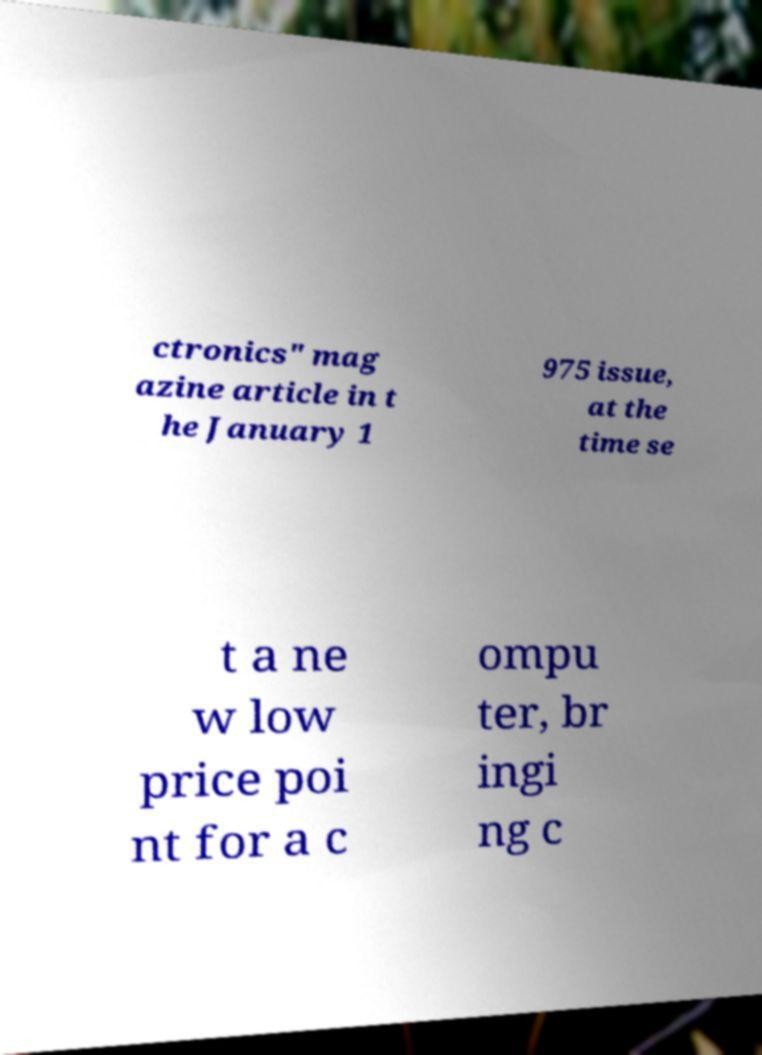Could you assist in decoding the text presented in this image and type it out clearly? ctronics" mag azine article in t he January 1 975 issue, at the time se t a ne w low price poi nt for a c ompu ter, br ingi ng c 